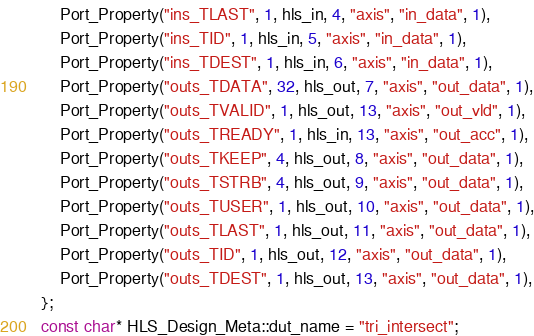Convert code to text. <code><loc_0><loc_0><loc_500><loc_500><_C++_>	Port_Property("ins_TLAST", 1, hls_in, 4, "axis", "in_data", 1),
	Port_Property("ins_TID", 1, hls_in, 5, "axis", "in_data", 1),
	Port_Property("ins_TDEST", 1, hls_in, 6, "axis", "in_data", 1),
	Port_Property("outs_TDATA", 32, hls_out, 7, "axis", "out_data", 1),
	Port_Property("outs_TVALID", 1, hls_out, 13, "axis", "out_vld", 1),
	Port_Property("outs_TREADY", 1, hls_in, 13, "axis", "out_acc", 1),
	Port_Property("outs_TKEEP", 4, hls_out, 8, "axis", "out_data", 1),
	Port_Property("outs_TSTRB", 4, hls_out, 9, "axis", "out_data", 1),
	Port_Property("outs_TUSER", 1, hls_out, 10, "axis", "out_data", 1),
	Port_Property("outs_TLAST", 1, hls_out, 11, "axis", "out_data", 1),
	Port_Property("outs_TID", 1, hls_out, 12, "axis", "out_data", 1),
	Port_Property("outs_TDEST", 1, hls_out, 13, "axis", "out_data", 1),
};
const char* HLS_Design_Meta::dut_name = "tri_intersect";
</code> 